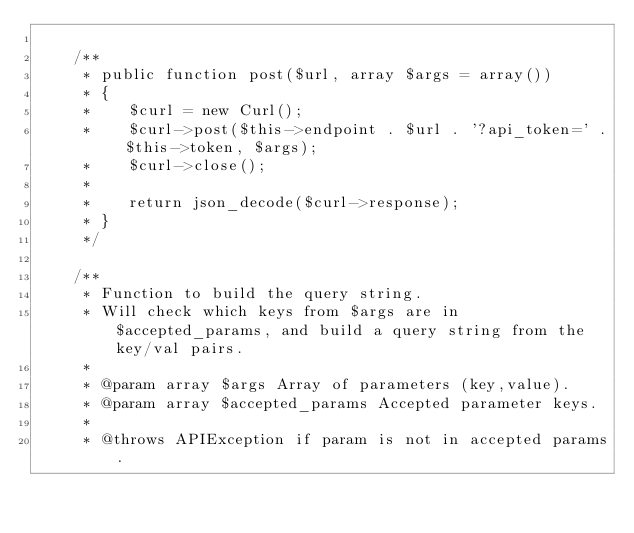<code> <loc_0><loc_0><loc_500><loc_500><_PHP_>
    /**
     * public function post($url, array $args = array())
     * {
     *    $curl = new Curl();
     *    $curl->post($this->endpoint . $url . '?api_token=' . $this->token, $args);
     *    $curl->close();
     *
     *    return json_decode($curl->response);
     * }
     */

    /**
     * Function to build the query string.
     * Will check which keys from $args are in $accepted_params, and build a query string from the key/val pairs.
     *
     * @param array $args Array of parameters (key,value).
     * @param array $accepted_params Accepted parameter keys.
     *
     * @throws APIException if param is not in accepted params.</code> 